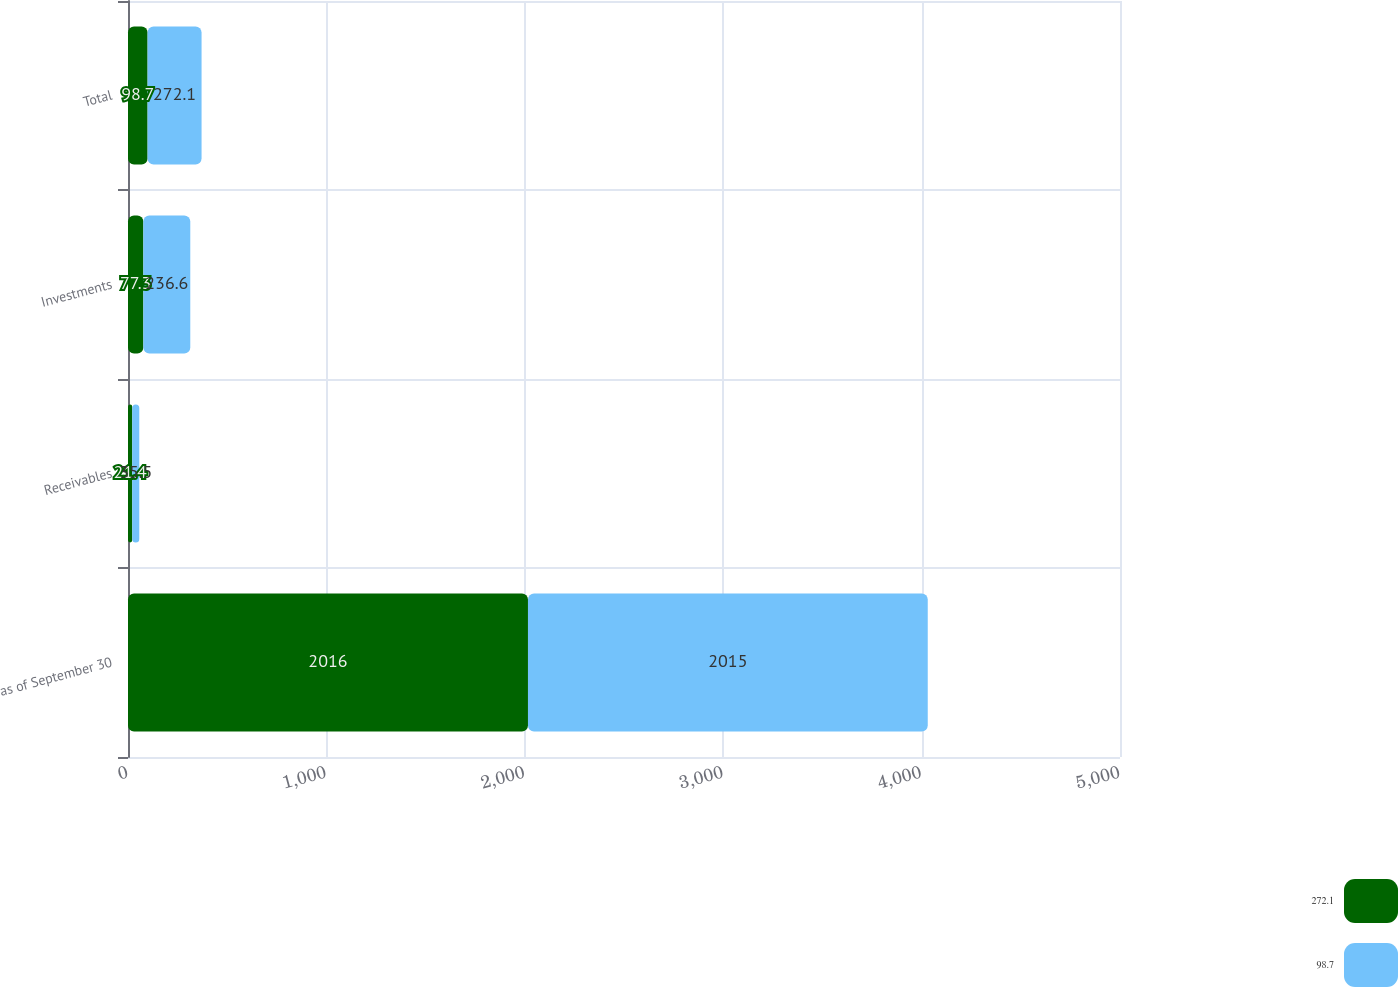Convert chart to OTSL. <chart><loc_0><loc_0><loc_500><loc_500><stacked_bar_chart><ecel><fcel>as of September 30<fcel>Receivables<fcel>Investments<fcel>Total<nl><fcel>272.1<fcel>2016<fcel>21.4<fcel>77.3<fcel>98.7<nl><fcel>98.7<fcel>2015<fcel>35.5<fcel>236.6<fcel>272.1<nl></chart> 